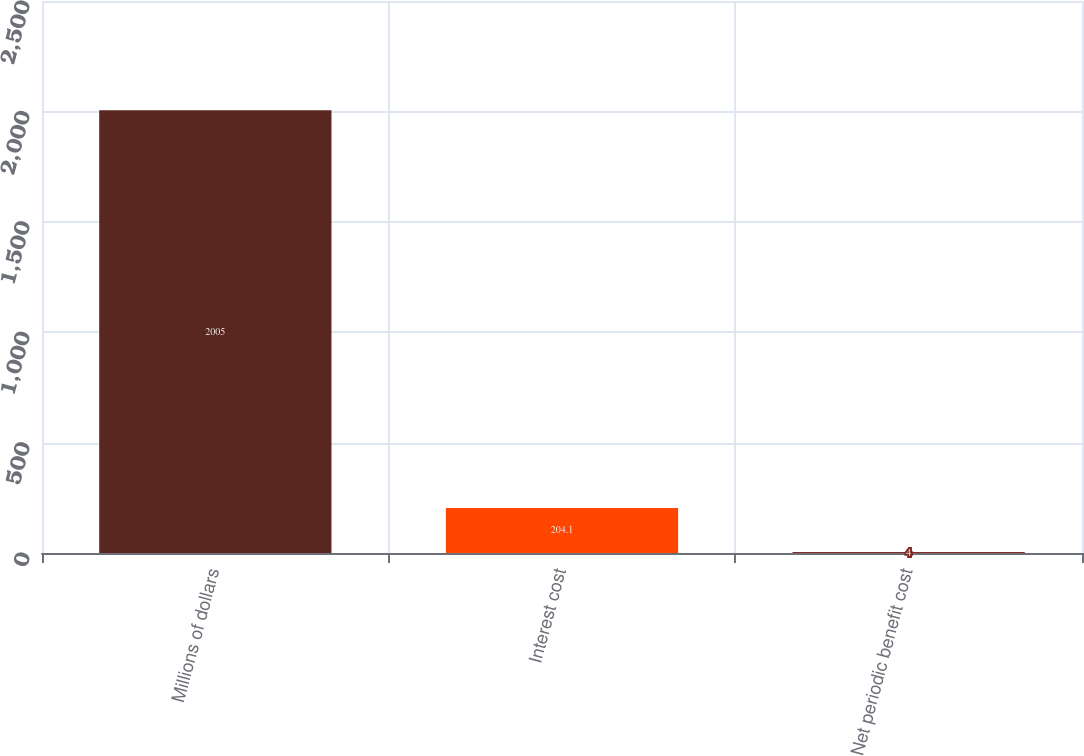<chart> <loc_0><loc_0><loc_500><loc_500><bar_chart><fcel>Millions of dollars<fcel>Interest cost<fcel>Net periodic benefit cost<nl><fcel>2005<fcel>204.1<fcel>4<nl></chart> 